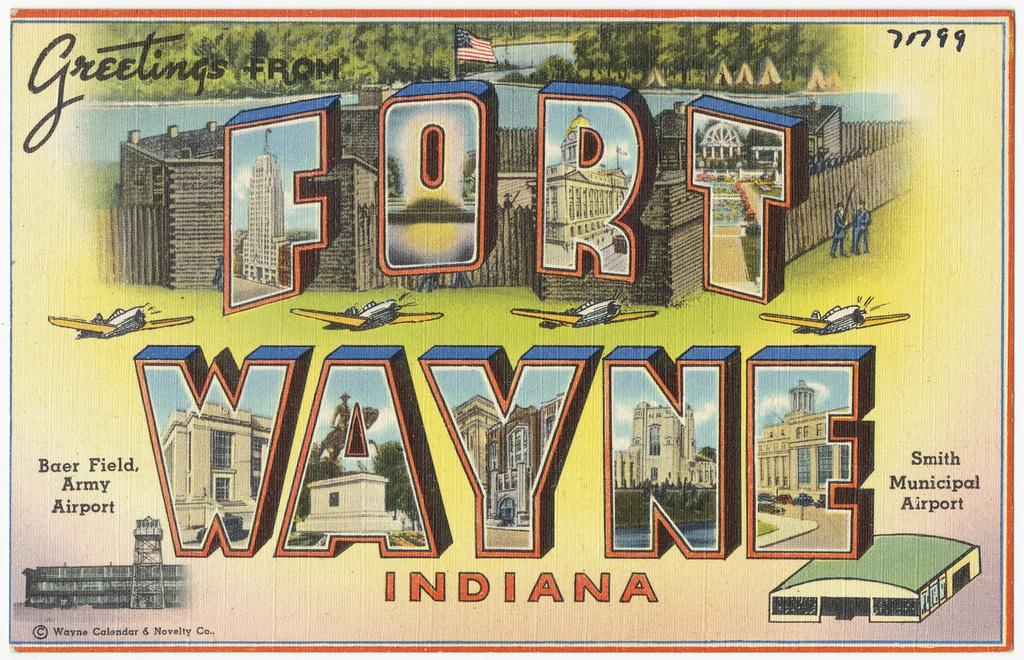<image>
Give a short and clear explanation of the subsequent image. A post card from Fort Wayne Indiana from Baer Field Army airport. 